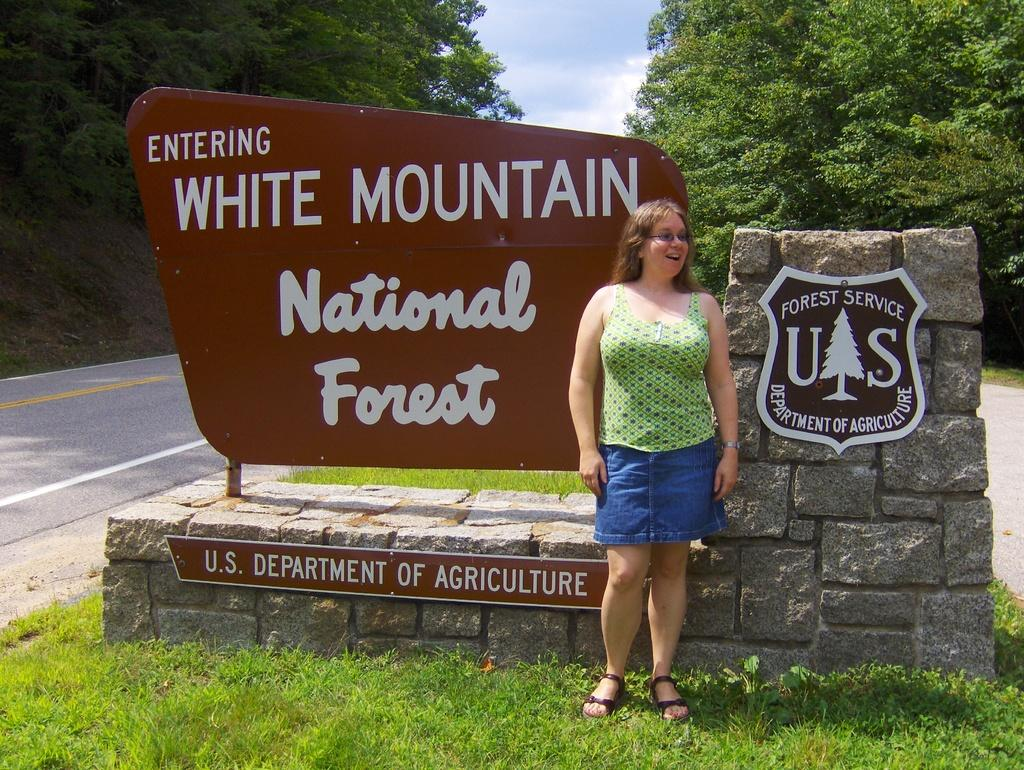What type of natural elements can be seen in the image? There are rocks, grass, and trees in the image. What is the woman in the image wearing? The woman is wearing a green dress in the image. What is visible at the top of the image? The sky is visible at the top of the image. What trick can be performed with the rocks in the image? There is no trick being performed with the rocks in the image; they are simply part of the natural landscape. 